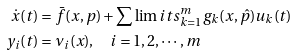<formula> <loc_0><loc_0><loc_500><loc_500>\dot { x } ( t ) & = \bar { f } ( x , p ) + \sum \lim i t s _ { k = 1 } ^ { m } { g _ { k } ( x , \hat { p } ) u _ { k } ( t ) } \\ y _ { i } ( t ) & = \nu _ { i } ( x ) , \quad i = 1 , 2 , \cdots , m \\</formula> 